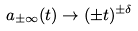Convert formula to latex. <formula><loc_0><loc_0><loc_500><loc_500>a _ { \pm \infty } ( t ) \rightarrow ( \pm t ) ^ { \pm \delta }</formula> 